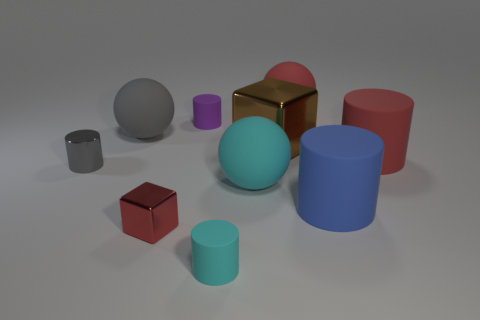Subtract all red cylinders. How many cylinders are left? 4 Subtract all gray shiny cylinders. How many cylinders are left? 4 Subtract 1 cylinders. How many cylinders are left? 4 Subtract all green cylinders. Subtract all brown spheres. How many cylinders are left? 5 Subtract all spheres. How many objects are left? 7 Add 8 small gray metal cylinders. How many small gray metal cylinders are left? 9 Add 4 matte cylinders. How many matte cylinders exist? 8 Subtract 0 green spheres. How many objects are left? 10 Subtract all big gray balls. Subtract all large green cylinders. How many objects are left? 9 